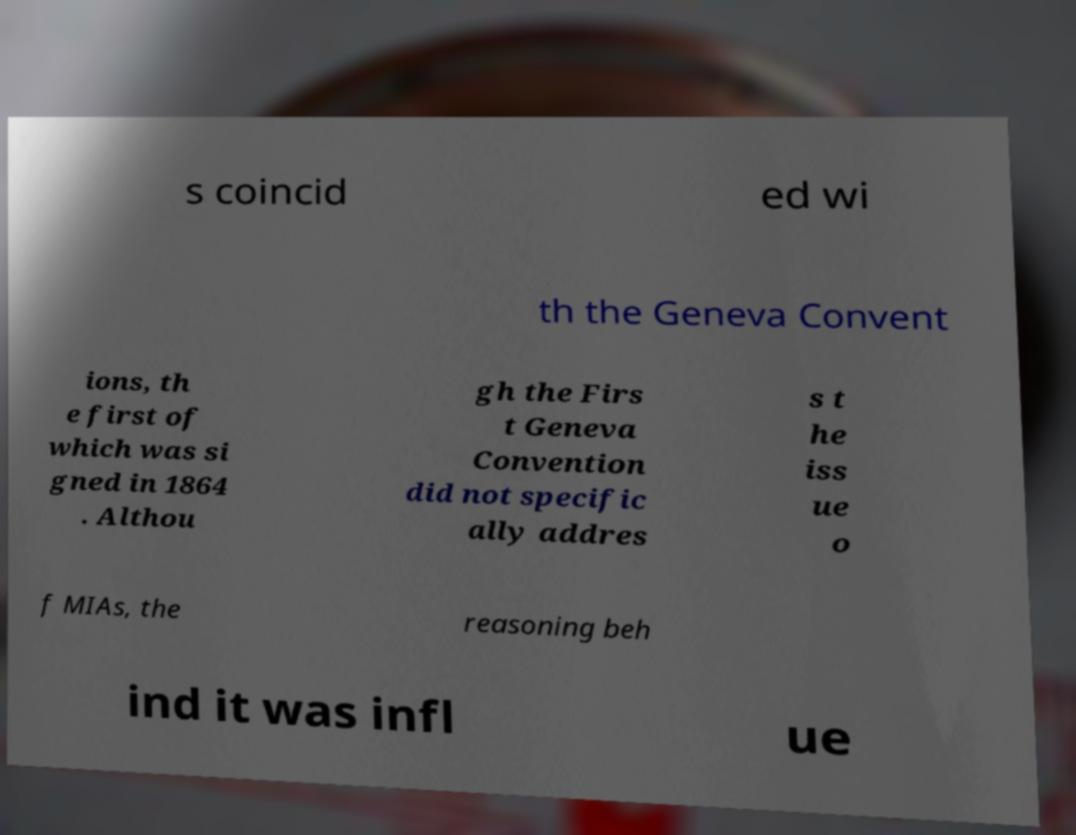Could you assist in decoding the text presented in this image and type it out clearly? s coincid ed wi th the Geneva Convent ions, th e first of which was si gned in 1864 . Althou gh the Firs t Geneva Convention did not specific ally addres s t he iss ue o f MIAs, the reasoning beh ind it was infl ue 